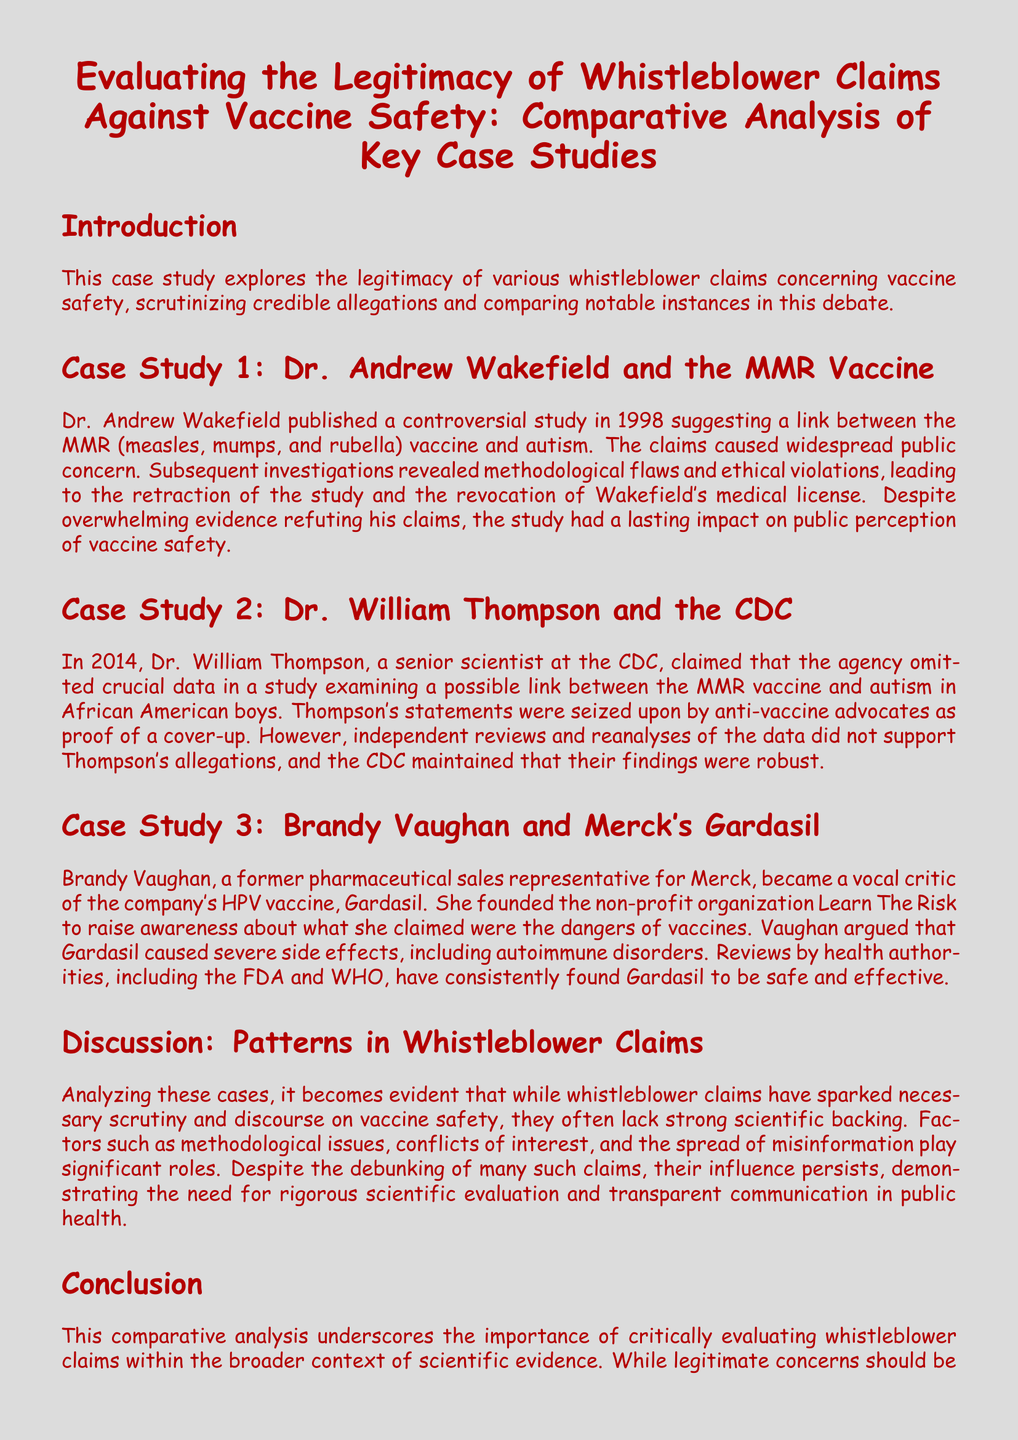What year was Dr. Andrew Wakefield's study published? The document states that Dr. Wakefield published his controversial study in 1998.
Answer: 1998 What vaccine is Dr. Andrew Wakefield associated with? The document mentions that Dr. Wakefield's claims were related to the MMR vaccine.
Answer: MMR vaccine Who made allegations regarding data suppression at the CDC? The document identifies Dr. William Thompson as the person who claimed data suppression at the CDC.
Answer: Dr. William Thompson What organization did Brandy Vaughan found? The document indicates that Brandy Vaughan founded the non-profit organization Learn The Risk.
Answer: Learn The Risk What methodological issues were present in the cases discussed? The document suggests that the cases often lacked strong scientific backing due to methodological issues.
Answer: Methodological issues How did independent reviews respond to Thompson's allegations? The document states that independent reviews and reanalyses of the data did not support Thompson's allegations.
Answer: Did not support What did health authorities conclude about Gardasil? The document notes that health authorities, including the FDA and WHO, found Gardasil to be safe and effective.
Answer: Safe and effective What is a common theme among the whistleblower claims? The document discusses that the whistleblower claims often lack strong scientific backing.
Answer: Lack of strong scientific backing What is the primary focus of the case study? The document's primary focus is evaluating the legitimacy of whistleblower claims against vaccine safety.
Answer: Evaluating the legitimacy of whistleblower claims against vaccine safety 